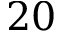Convert formula to latex. <formula><loc_0><loc_0><loc_500><loc_500>2 0</formula> 